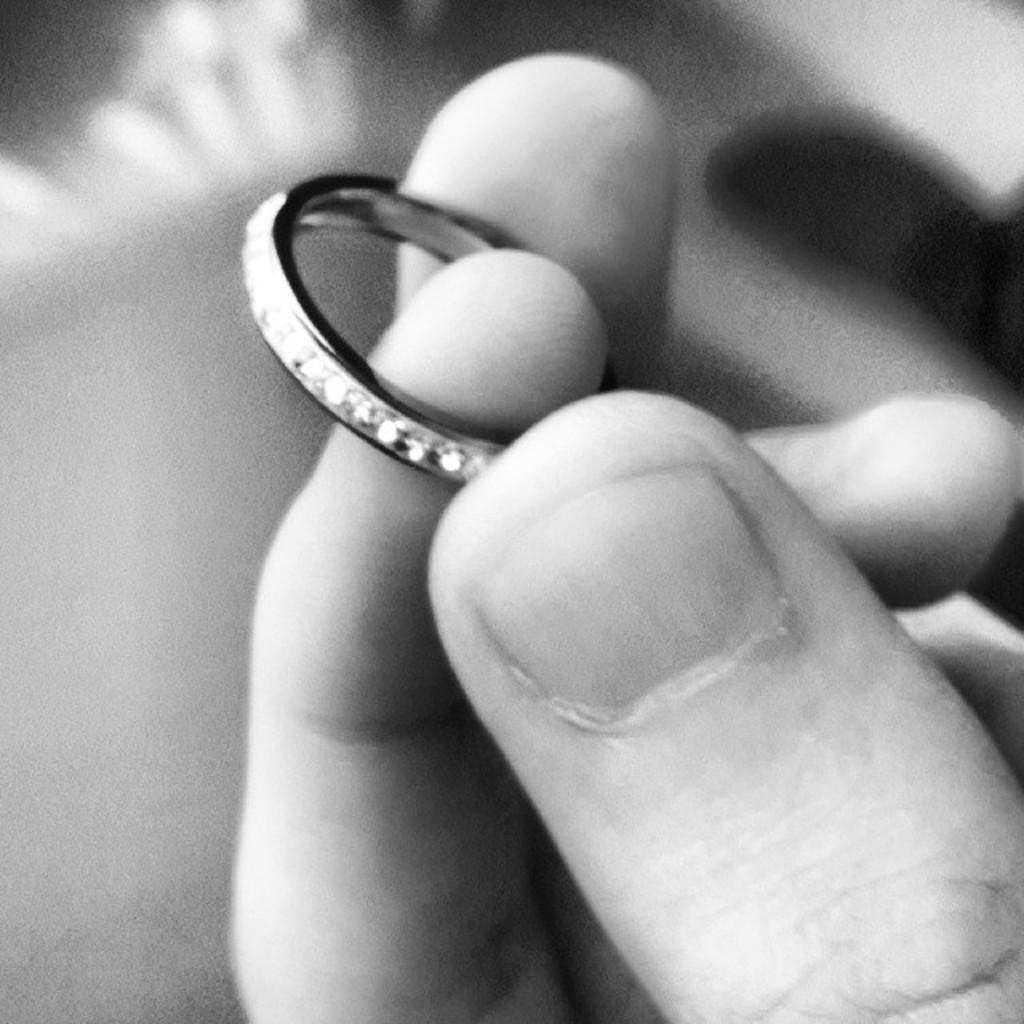What part of the human body is visible in the image? There are human fingers visible in the image. What is on the fingers in the image? The fingers have a ring on them. Can you describe the background of the image? The background of the image is blurred. What type of vegetable is being used as a badge in the image? There is no vegetable being used as a badge in the image. What type of board is visible in the image? There is no board present in the image. 